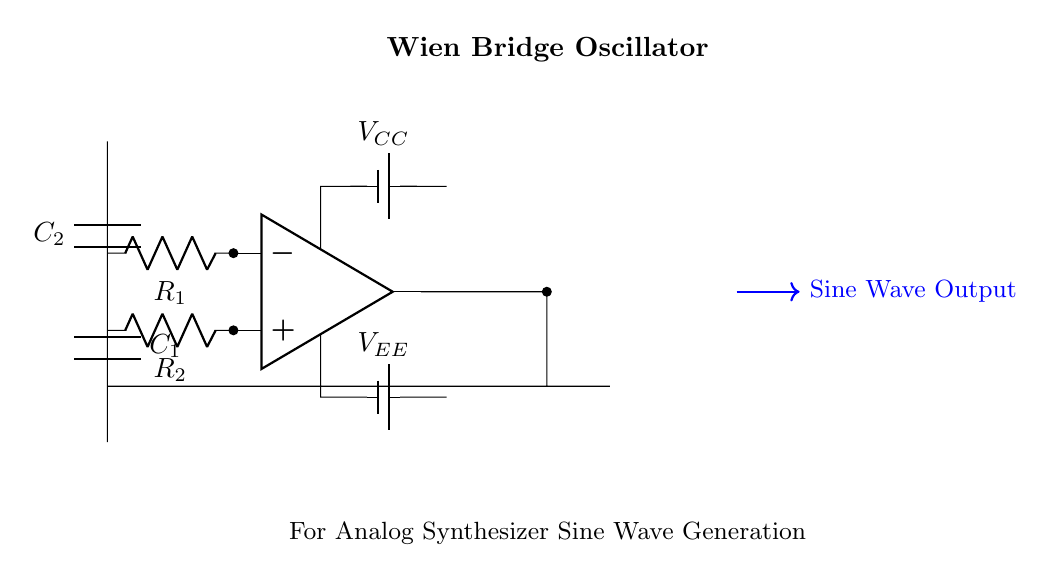What type of circuit is represented? This circuit is labeled as a Wiener Bridge Oscillator, indicating that it is specifically designed to generate sine waves. The name is explicitly mentioned in the diagram.
Answer: Wien Bridge Oscillator What are the two resistors in the circuit? The circuit diagram contains two resistors labeled as R1 and R2, which are seen connecting to the inverting and non-inverting inputs of the operational amplifier.
Answer: R1 and R2 What is the type of output waveform generated? The output is described as a sine wave, which is typically generated in a Wien Bridge Oscillator circuit due to its specific configuration of components.
Answer: Sine Wave What is the purpose of capacitors in this circuit? Capacitors C1 and C2 form part of the feedback network in the Wien Bridge design, influencing the frequency of oscillation and helping to stabilize the output sine wave.
Answer: Frequency control What is the role of the operational amplifier in this circuit? The operational amplifier is crucial for amplifying the output signal and providing the necessary gain for oscillation. It's positioned centrally within the circuit diagram for this purpose.
Answer: Signal amplification How are the resistors connected to each other? Resistors R1 and R2 are connected in a feedback loop with the capacitors, forming a parallel/series combination that contributes to the oscillator's frequency determination.
Answer: Feedback network What power source is used in this circuit? The circuit has two power sources labeled as VCC and VEE that supply positive and negative voltages to the operational amplifier, ensuring it has the power to operate effectively.
Answer: VCC and VEE 